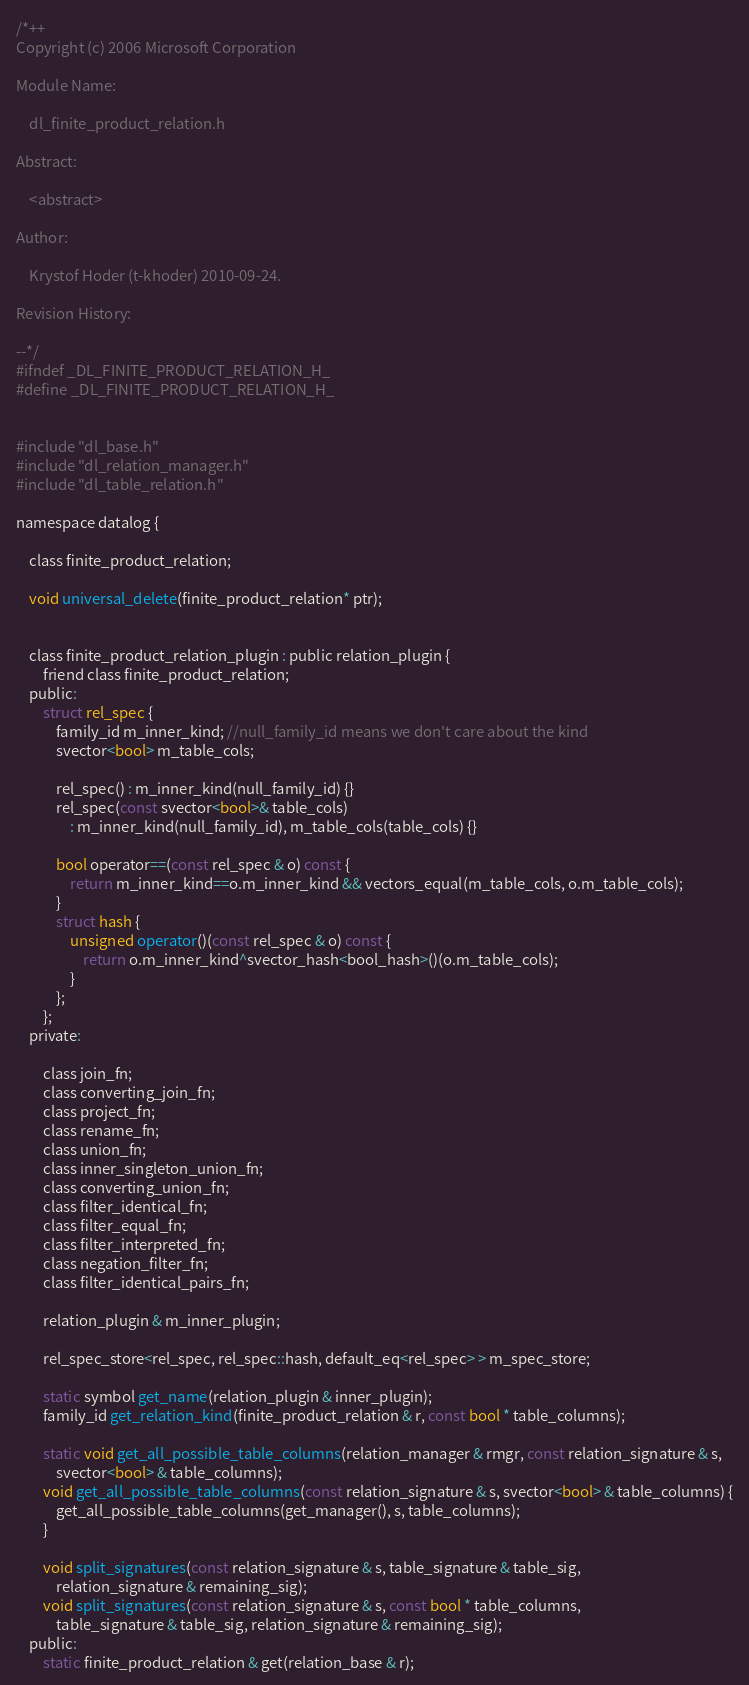Convert code to text. <code><loc_0><loc_0><loc_500><loc_500><_C_>/*++
Copyright (c) 2006 Microsoft Corporation

Module Name:

    dl_finite_product_relation.h

Abstract:

    <abstract>

Author:

    Krystof Hoder (t-khoder) 2010-09-24.

Revision History:

--*/
#ifndef _DL_FINITE_PRODUCT_RELATION_H_
#define _DL_FINITE_PRODUCT_RELATION_H_


#include "dl_base.h"
#include "dl_relation_manager.h"
#include "dl_table_relation.h"

namespace datalog {

    class finite_product_relation;

    void universal_delete(finite_product_relation* ptr);


    class finite_product_relation_plugin : public relation_plugin {
        friend class finite_product_relation;
    public:
        struct rel_spec {
            family_id m_inner_kind; //null_family_id means we don't care about the kind
            svector<bool> m_table_cols;

            rel_spec() : m_inner_kind(null_family_id) {}
            rel_spec(const svector<bool>& table_cols) 
                : m_inner_kind(null_family_id), m_table_cols(table_cols) {}

            bool operator==(const rel_spec & o) const {
                return m_inner_kind==o.m_inner_kind && vectors_equal(m_table_cols, o.m_table_cols);
            }
            struct hash {
                unsigned operator()(const rel_spec & o) const {
                    return o.m_inner_kind^svector_hash<bool_hash>()(o.m_table_cols);
                }
            };
        };
    private:

        class join_fn;
        class converting_join_fn;
        class project_fn;
        class rename_fn;
        class union_fn;
        class inner_singleton_union_fn;
        class converting_union_fn;
        class filter_identical_fn;
        class filter_equal_fn;
        class filter_interpreted_fn;
        class negation_filter_fn;
        class filter_identical_pairs_fn;

        relation_plugin & m_inner_plugin;

        rel_spec_store<rel_spec, rel_spec::hash, default_eq<rel_spec> > m_spec_store;

        static symbol get_name(relation_plugin & inner_plugin);
        family_id get_relation_kind(finite_product_relation & r, const bool * table_columns);

        static void get_all_possible_table_columns(relation_manager & rmgr, const relation_signature & s, 
            svector<bool> & table_columns);
        void get_all_possible_table_columns(const relation_signature & s, svector<bool> & table_columns) {
            get_all_possible_table_columns(get_manager(), s, table_columns);
        }

        void split_signatures(const relation_signature & s, table_signature & table_sig, 
            relation_signature & remaining_sig);
        void split_signatures(const relation_signature & s, const bool * table_columns, 
            table_signature & table_sig, relation_signature & remaining_sig);
    public:
        static finite_product_relation & get(relation_base & r);</code> 